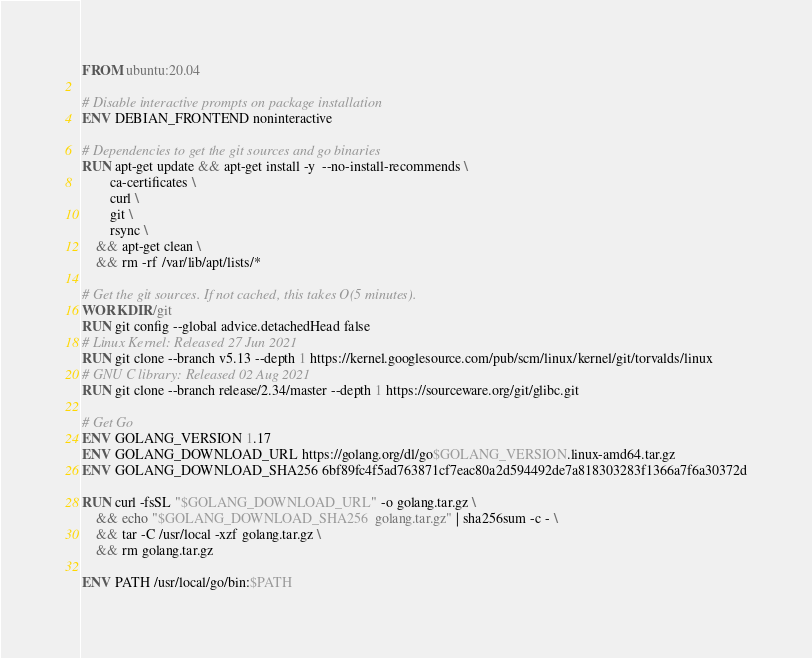Convert code to text. <code><loc_0><loc_0><loc_500><loc_500><_Dockerfile_>FROM ubuntu:20.04

# Disable interactive prompts on package installation
ENV DEBIAN_FRONTEND noninteractive

# Dependencies to get the git sources and go binaries
RUN apt-get update && apt-get install -y  --no-install-recommends \
        ca-certificates \
        curl \
        git \
        rsync \
    && apt-get clean \
    && rm -rf /var/lib/apt/lists/*

# Get the git sources. If not cached, this takes O(5 minutes).
WORKDIR /git
RUN git config --global advice.detachedHead false
# Linux Kernel: Released 27 Jun 2021
RUN git clone --branch v5.13 --depth 1 https://kernel.googlesource.com/pub/scm/linux/kernel/git/torvalds/linux
# GNU C library: Released 02 Aug 2021
RUN git clone --branch release/2.34/master --depth 1 https://sourceware.org/git/glibc.git

# Get Go
ENV GOLANG_VERSION 1.17
ENV GOLANG_DOWNLOAD_URL https://golang.org/dl/go$GOLANG_VERSION.linux-amd64.tar.gz
ENV GOLANG_DOWNLOAD_SHA256 6bf89fc4f5ad763871cf7eac80a2d594492de7a818303283f1366a7f6a30372d

RUN curl -fsSL "$GOLANG_DOWNLOAD_URL" -o golang.tar.gz \
    && echo "$GOLANG_DOWNLOAD_SHA256  golang.tar.gz" | sha256sum -c - \
    && tar -C /usr/local -xzf golang.tar.gz \
    && rm golang.tar.gz

ENV PATH /usr/local/go/bin:$PATH
</code> 